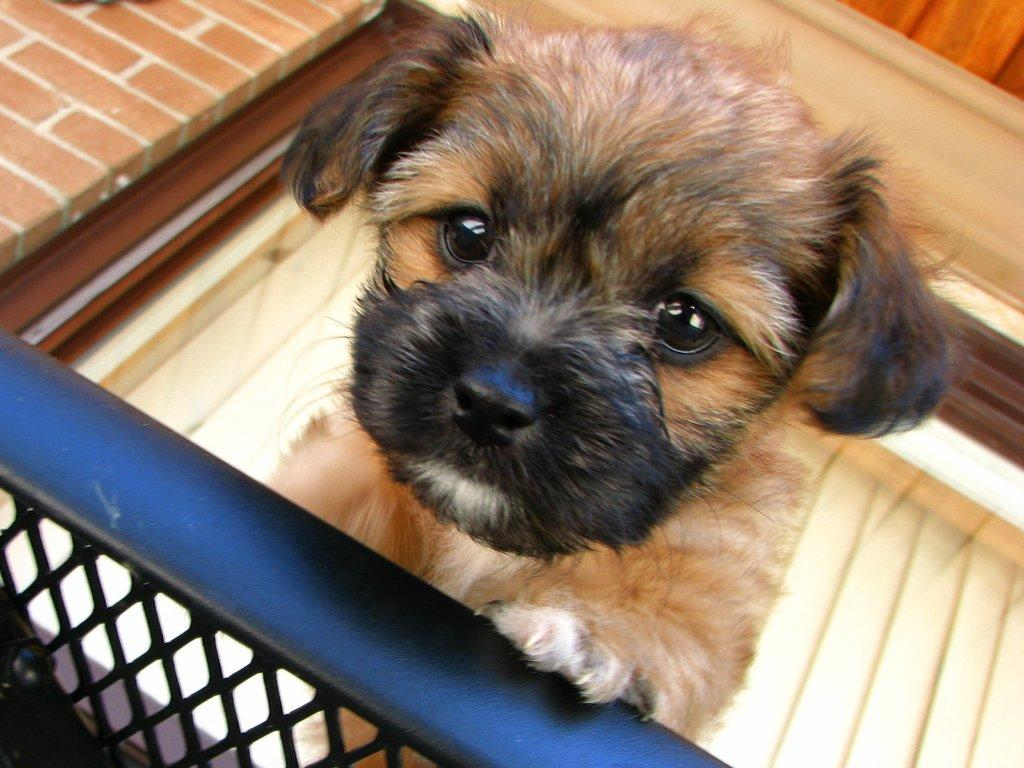What is the main subject of the image? There is a puppy in the image. What is the puppy looking at? The puppy is looking at a picture. What can be seen at the bottom of the image? There is a railing at the bottom of the image. What is visible in the background of the image? There is a wall in the background of the image. Where is the image located? The image is part of a building. What type of trade is the puppy participating in with its partner in the image? There is no partner or trade present in the image; it features a puppy looking at a picture. What is the competition between the puppy and the wall in the image? There is no competition between the puppy and the wall in the image; the puppy is simply looking at a picture, and the wall is in the background. 